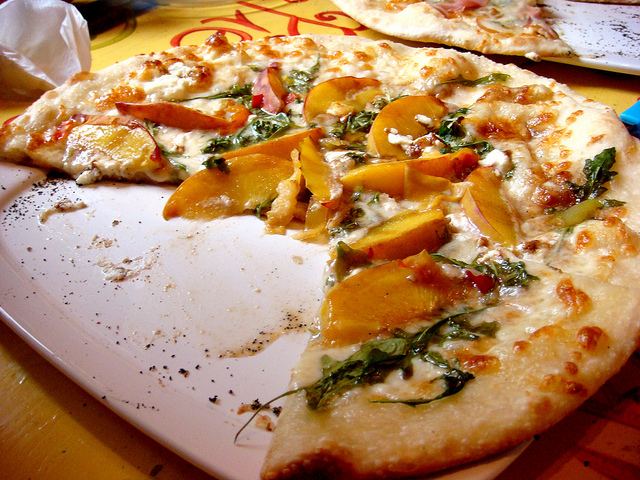What type of food is shown in the picture? The image displays a partially eaten pizza with various toppings, including what appear to be slices of yellow bell pepper and herbs, indicative of a flavorful and savory dish. 